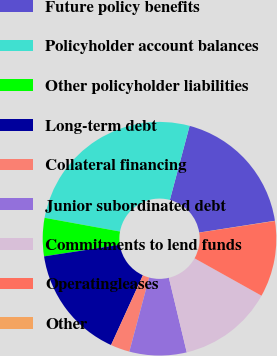Convert chart. <chart><loc_0><loc_0><loc_500><loc_500><pie_chart><fcel>Future policy benefits<fcel>Policyholder account balances<fcel>Other policyholder liabilities<fcel>Long-term debt<fcel>Collateral financing<fcel>Junior subordinated debt<fcel>Commitments to lend funds<fcel>Operatingleases<fcel>Other<nl><fcel>18.4%<fcel>26.28%<fcel>5.28%<fcel>15.78%<fcel>2.65%<fcel>7.9%<fcel>13.15%<fcel>10.53%<fcel>0.03%<nl></chart> 